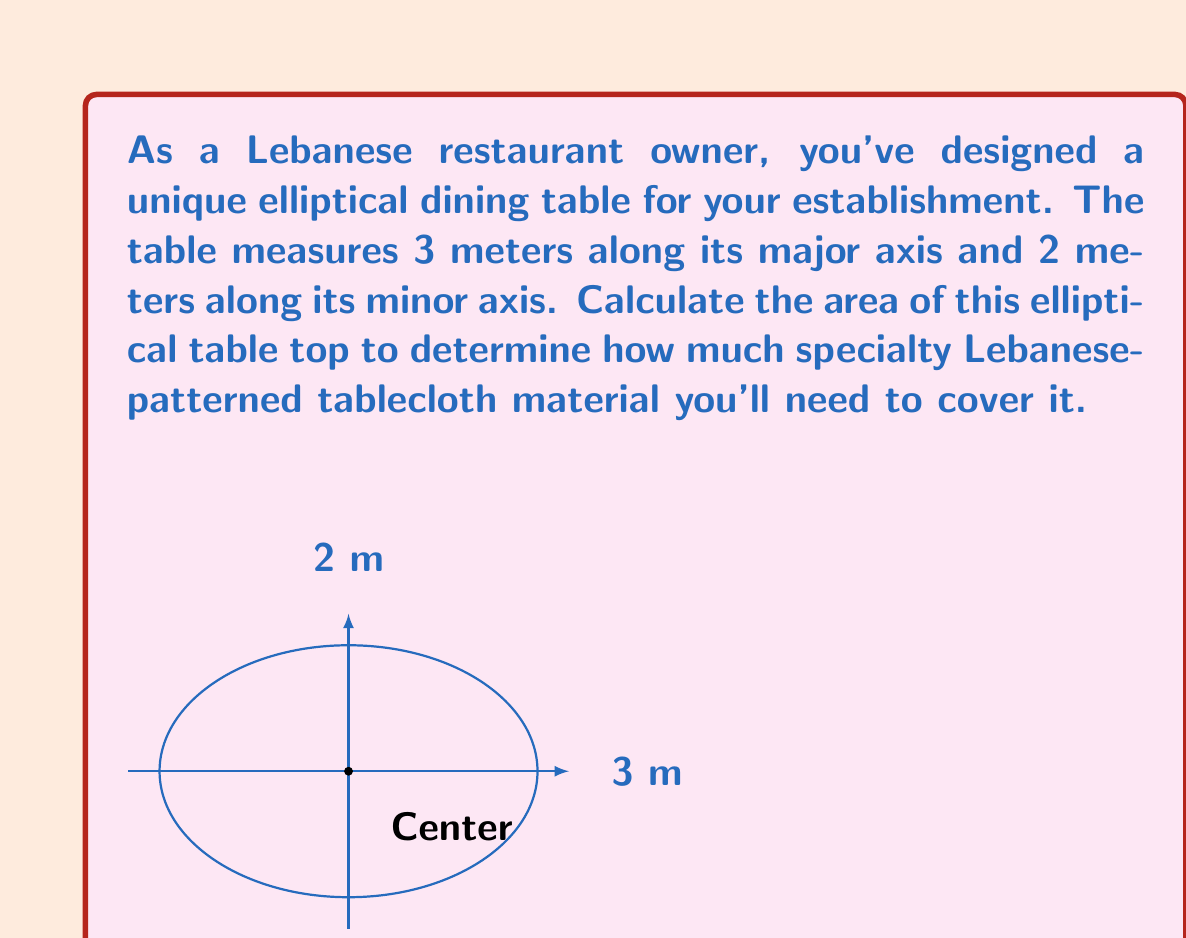What is the answer to this math problem? To calculate the area of an elliptical table, we use the formula:

$$A = \pi ab$$

Where:
$A$ = Area of the ellipse
$a$ = Length of the semi-major axis (half of the major axis)
$b$ = Length of the semi-minor axis (half of the minor axis)

Given:
- Major axis = 3 meters
- Minor axis = 2 meters

Step 1: Determine the semi-major and semi-minor axes
$a = 3 \div 2 = 1.5$ meters
$b = 2 \div 2 = 1$ meter

Step 2: Apply the formula
$$A = \pi ab$$
$$A = \pi (1.5)(1)$$

Step 3: Calculate the result
$$A = 1.5\pi \approx 4.71239 \text{ square meters}$$

Therefore, the area of the elliptical dining table is approximately 4.71 square meters.
Answer: $4.71 \text{ m}^2$ 